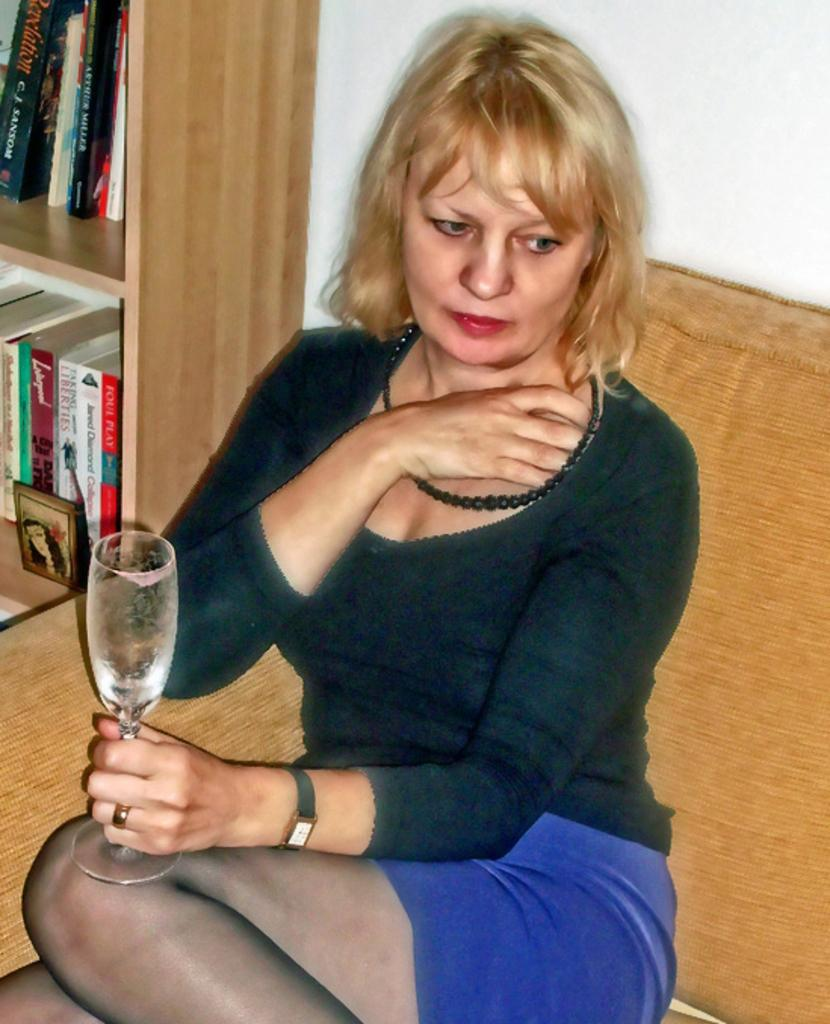What is the lady doing in the image? There is a lady sitting on a couch in the image. What is the lady holding in the image? The lady is holding a drink glass in the image. What can be seen in the background of the image? There are many books placed in a wood rack in the background of the image. How many children are playing with the lady's shirt in the image? There are no children present in the image, nor is there any mention of a shirt being played with. 